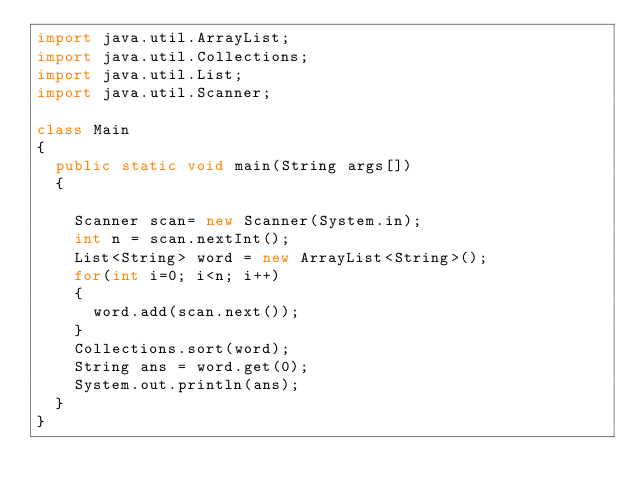<code> <loc_0><loc_0><loc_500><loc_500><_Java_>import java.util.ArrayList;
import java.util.Collections;
import java.util.List;
import java.util.Scanner;

class Main
{
	public static void main(String args[])
	{

		Scanner scan= new Scanner(System.in);
		int n = scan.nextInt();
		List<String> word = new ArrayList<String>();
		for(int i=0; i<n; i++)
		{
			word.add(scan.next());
		}
		Collections.sort(word);
		String ans = word.get(0);
		System.out.println(ans);
	}
}</code> 